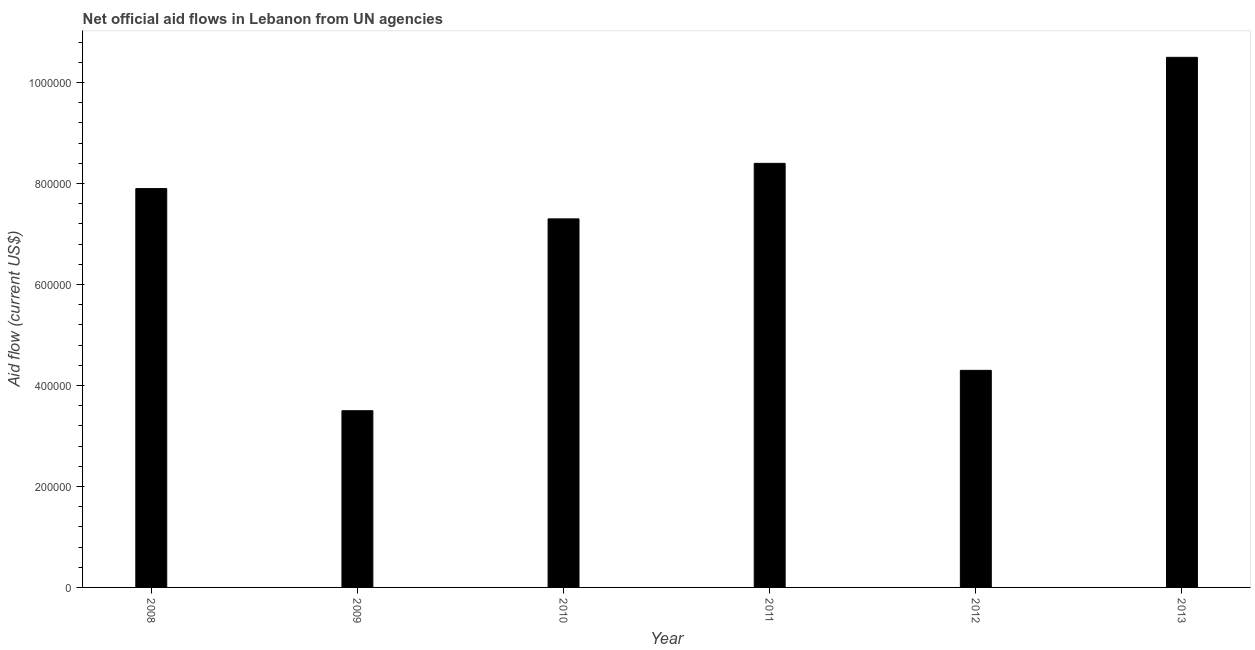What is the title of the graph?
Offer a terse response. Net official aid flows in Lebanon from UN agencies. What is the label or title of the X-axis?
Give a very brief answer. Year. Across all years, what is the maximum net official flows from un agencies?
Give a very brief answer. 1.05e+06. In which year was the net official flows from un agencies minimum?
Your response must be concise. 2009. What is the sum of the net official flows from un agencies?
Provide a succinct answer. 4.19e+06. What is the difference between the net official flows from un agencies in 2010 and 2012?
Give a very brief answer. 3.00e+05. What is the average net official flows from un agencies per year?
Offer a very short reply. 6.98e+05. What is the median net official flows from un agencies?
Offer a very short reply. 7.60e+05. In how many years, is the net official flows from un agencies greater than 200000 US$?
Provide a succinct answer. 6. What is the ratio of the net official flows from un agencies in 2008 to that in 2013?
Keep it short and to the point. 0.75. Is the net official flows from un agencies in 2010 less than that in 2011?
Your answer should be very brief. Yes. What is the difference between the highest and the second highest net official flows from un agencies?
Offer a terse response. 2.10e+05. In how many years, is the net official flows from un agencies greater than the average net official flows from un agencies taken over all years?
Offer a very short reply. 4. How many bars are there?
Make the answer very short. 6. How many years are there in the graph?
Give a very brief answer. 6. Are the values on the major ticks of Y-axis written in scientific E-notation?
Offer a terse response. No. What is the Aid flow (current US$) in 2008?
Make the answer very short. 7.90e+05. What is the Aid flow (current US$) in 2009?
Provide a short and direct response. 3.50e+05. What is the Aid flow (current US$) of 2010?
Keep it short and to the point. 7.30e+05. What is the Aid flow (current US$) in 2011?
Provide a short and direct response. 8.40e+05. What is the Aid flow (current US$) of 2013?
Ensure brevity in your answer.  1.05e+06. What is the difference between the Aid flow (current US$) in 2008 and 2010?
Your response must be concise. 6.00e+04. What is the difference between the Aid flow (current US$) in 2008 and 2012?
Offer a terse response. 3.60e+05. What is the difference between the Aid flow (current US$) in 2008 and 2013?
Give a very brief answer. -2.60e+05. What is the difference between the Aid flow (current US$) in 2009 and 2010?
Ensure brevity in your answer.  -3.80e+05. What is the difference between the Aid flow (current US$) in 2009 and 2011?
Your response must be concise. -4.90e+05. What is the difference between the Aid flow (current US$) in 2009 and 2012?
Provide a succinct answer. -8.00e+04. What is the difference between the Aid flow (current US$) in 2009 and 2013?
Offer a very short reply. -7.00e+05. What is the difference between the Aid flow (current US$) in 2010 and 2012?
Keep it short and to the point. 3.00e+05. What is the difference between the Aid flow (current US$) in 2010 and 2013?
Provide a short and direct response. -3.20e+05. What is the difference between the Aid flow (current US$) in 2011 and 2012?
Provide a short and direct response. 4.10e+05. What is the difference between the Aid flow (current US$) in 2011 and 2013?
Offer a terse response. -2.10e+05. What is the difference between the Aid flow (current US$) in 2012 and 2013?
Your answer should be very brief. -6.20e+05. What is the ratio of the Aid flow (current US$) in 2008 to that in 2009?
Provide a succinct answer. 2.26. What is the ratio of the Aid flow (current US$) in 2008 to that in 2010?
Provide a short and direct response. 1.08. What is the ratio of the Aid flow (current US$) in 2008 to that in 2012?
Offer a very short reply. 1.84. What is the ratio of the Aid flow (current US$) in 2008 to that in 2013?
Give a very brief answer. 0.75. What is the ratio of the Aid flow (current US$) in 2009 to that in 2010?
Give a very brief answer. 0.48. What is the ratio of the Aid flow (current US$) in 2009 to that in 2011?
Offer a terse response. 0.42. What is the ratio of the Aid flow (current US$) in 2009 to that in 2012?
Provide a succinct answer. 0.81. What is the ratio of the Aid flow (current US$) in 2009 to that in 2013?
Keep it short and to the point. 0.33. What is the ratio of the Aid flow (current US$) in 2010 to that in 2011?
Give a very brief answer. 0.87. What is the ratio of the Aid flow (current US$) in 2010 to that in 2012?
Ensure brevity in your answer.  1.7. What is the ratio of the Aid flow (current US$) in 2010 to that in 2013?
Give a very brief answer. 0.69. What is the ratio of the Aid flow (current US$) in 2011 to that in 2012?
Your response must be concise. 1.95. What is the ratio of the Aid flow (current US$) in 2011 to that in 2013?
Ensure brevity in your answer.  0.8. What is the ratio of the Aid flow (current US$) in 2012 to that in 2013?
Make the answer very short. 0.41. 